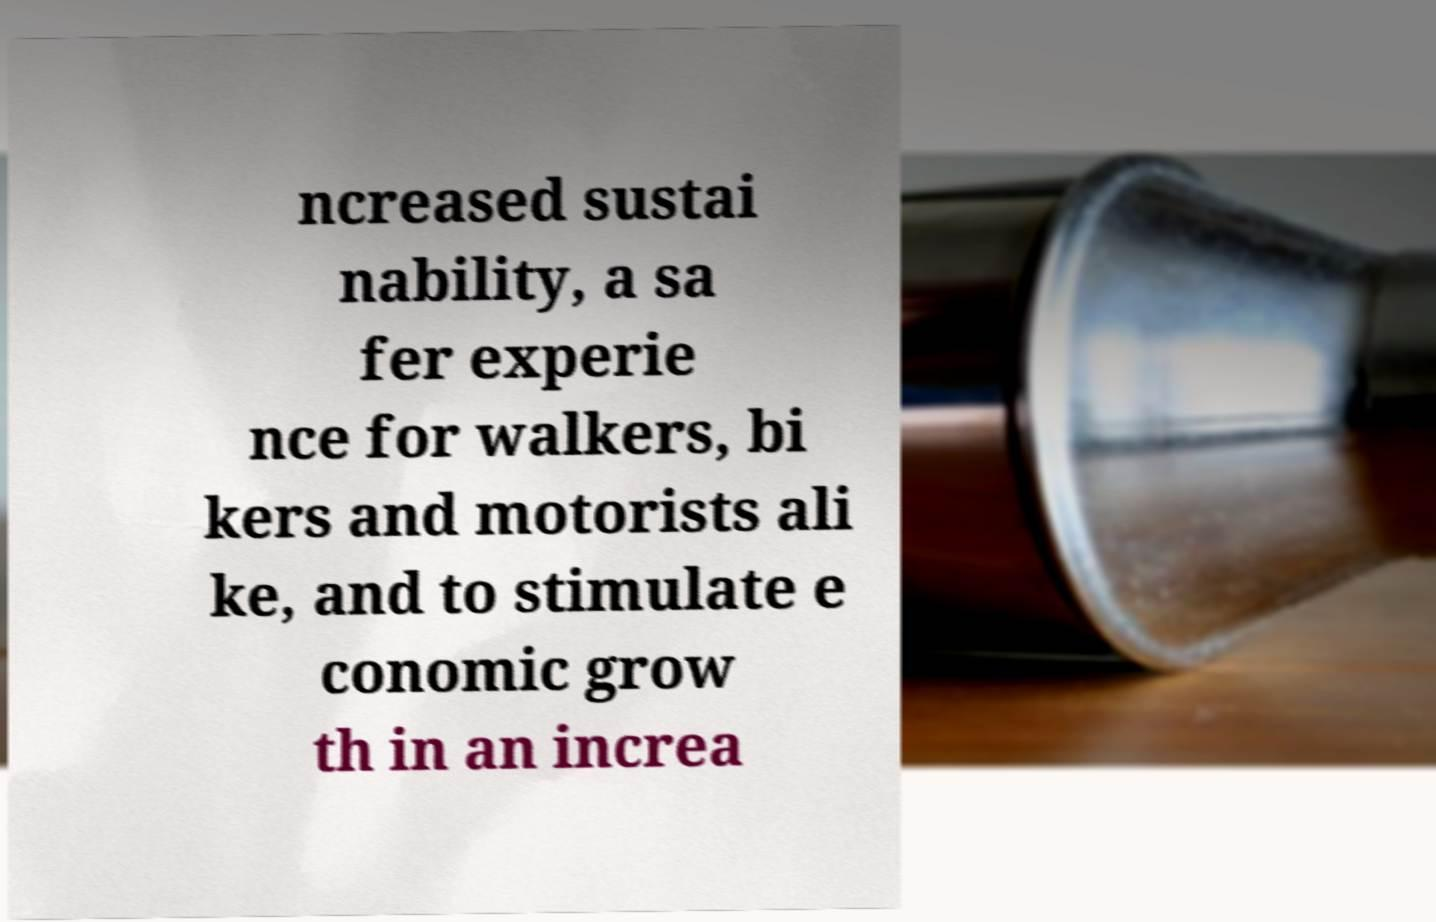Can you read and provide the text displayed in the image?This photo seems to have some interesting text. Can you extract and type it out for me? ncreased sustai nability, a sa fer experie nce for walkers, bi kers and motorists ali ke, and to stimulate e conomic grow th in an increa 